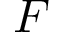<formula> <loc_0><loc_0><loc_500><loc_500>F</formula> 